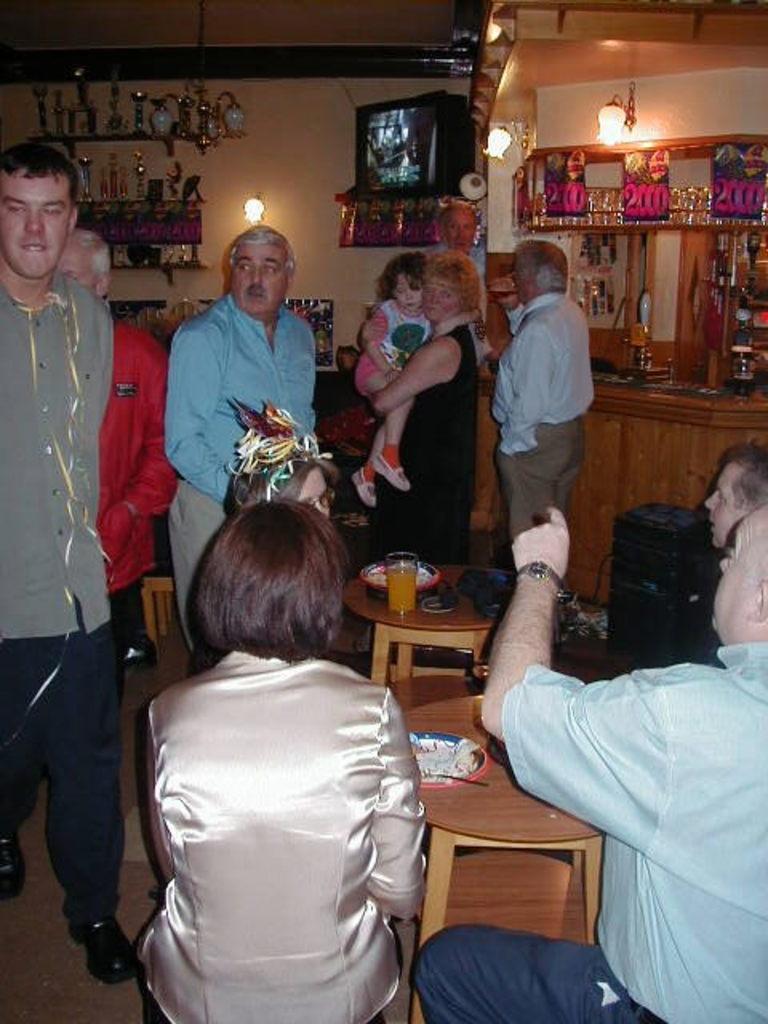Please provide a concise description of this image. In this picture there is a room in which some of them were standing and some of them was sitting in the chairs in front of a table. In the background there are some lights and shelves here. 